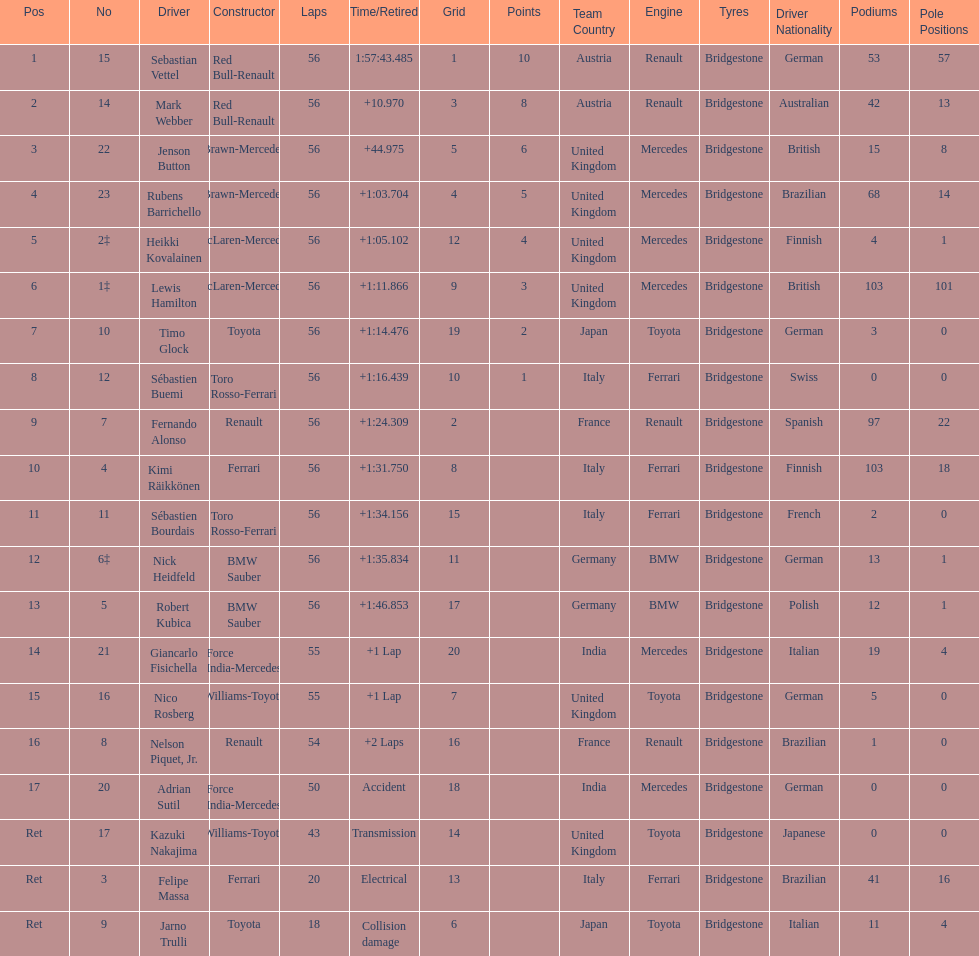Could you help me parse every detail presented in this table? {'header': ['Pos', 'No', 'Driver', 'Constructor', 'Laps', 'Time/Retired', 'Grid', 'Points', 'Team Country', 'Engine', 'Tyres', 'Driver Nationality', 'Podiums', 'Pole Positions'], 'rows': [['1', '15', 'Sebastian Vettel', 'Red Bull-Renault', '56', '1:57:43.485', '1', '10', 'Austria', 'Renault', 'Bridgestone', 'German', '53', '57'], ['2', '14', 'Mark Webber', 'Red Bull-Renault', '56', '+10.970', '3', '8', 'Austria', 'Renault', 'Bridgestone', 'Australian', '42', '13'], ['3', '22', 'Jenson Button', 'Brawn-Mercedes', '56', '+44.975', '5', '6', 'United Kingdom', 'Mercedes', 'Bridgestone', 'British', '15', '8'], ['4', '23', 'Rubens Barrichello', 'Brawn-Mercedes', '56', '+1:03.704', '4', '5', 'United Kingdom', 'Mercedes', 'Bridgestone', 'Brazilian', '68', '14'], ['5', '2‡', 'Heikki Kovalainen', 'McLaren-Mercedes', '56', '+1:05.102', '12', '4', 'United Kingdom', 'Mercedes', 'Bridgestone', 'Finnish', '4', '1'], ['6', '1‡', 'Lewis Hamilton', 'McLaren-Mercedes', '56', '+1:11.866', '9', '3', 'United Kingdom', 'Mercedes', 'Bridgestone', 'British', '103', '101'], ['7', '10', 'Timo Glock', 'Toyota', '56', '+1:14.476', '19', '2', 'Japan', 'Toyota', 'Bridgestone', 'German', '3', '0'], ['8', '12', 'Sébastien Buemi', 'Toro Rosso-Ferrari', '56', '+1:16.439', '10', '1', 'Italy', 'Ferrari', 'Bridgestone', 'Swiss', '0', '0'], ['9', '7', 'Fernando Alonso', 'Renault', '56', '+1:24.309', '2', '', 'France', 'Renault', 'Bridgestone', 'Spanish', '97', '22'], ['10', '4', 'Kimi Räikkönen', 'Ferrari', '56', '+1:31.750', '8', '', 'Italy', 'Ferrari', 'Bridgestone', 'Finnish', '103', '18'], ['11', '11', 'Sébastien Bourdais', 'Toro Rosso-Ferrari', '56', '+1:34.156', '15', '', 'Italy', 'Ferrari', 'Bridgestone', 'French', '2', '0'], ['12', '6‡', 'Nick Heidfeld', 'BMW Sauber', '56', '+1:35.834', '11', '', 'Germany', 'BMW', 'Bridgestone', 'German', '13', '1'], ['13', '5', 'Robert Kubica', 'BMW Sauber', '56', '+1:46.853', '17', '', 'Germany', 'BMW', 'Bridgestone', 'Polish', '12', '1'], ['14', '21', 'Giancarlo Fisichella', 'Force India-Mercedes', '55', '+1 Lap', '20', '', 'India', 'Mercedes', 'Bridgestone', 'Italian', '19', '4'], ['15', '16', 'Nico Rosberg', 'Williams-Toyota', '55', '+1 Lap', '7', '', 'United Kingdom', 'Toyota', 'Bridgestone', 'German', '5', '0'], ['16', '8', 'Nelson Piquet, Jr.', 'Renault', '54', '+2 Laps', '16', '', 'France', 'Renault', 'Bridgestone', 'Brazilian', '1', '0'], ['17', '20', 'Adrian Sutil', 'Force India-Mercedes', '50', 'Accident', '18', '', 'India', 'Mercedes', 'Bridgestone', 'German', '0', '0'], ['Ret', '17', 'Kazuki Nakajima', 'Williams-Toyota', '43', 'Transmission', '14', '', 'United Kingdom', 'Toyota', 'Bridgestone', 'Japanese', '0', '0'], ['Ret', '3', 'Felipe Massa', 'Ferrari', '20', 'Electrical', '13', '', 'Italy', 'Ferrari', 'Bridgestone', 'Brazilian', '41', '16'], ['Ret', '9', 'Jarno Trulli', 'Toyota', '18', 'Collision damage', '6', '', 'Japan', 'Toyota', 'Bridgestone', 'Italian', '11', '4']]} How many laps in total is the race? 56. 